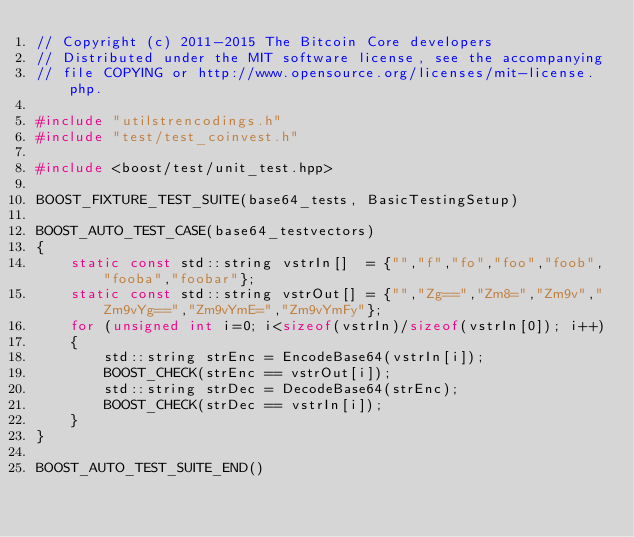<code> <loc_0><loc_0><loc_500><loc_500><_C++_>// Copyright (c) 2011-2015 The Bitcoin Core developers
// Distributed under the MIT software license, see the accompanying
// file COPYING or http://www.opensource.org/licenses/mit-license.php.

#include "utilstrencodings.h"
#include "test/test_coinvest.h"

#include <boost/test/unit_test.hpp>

BOOST_FIXTURE_TEST_SUITE(base64_tests, BasicTestingSetup)

BOOST_AUTO_TEST_CASE(base64_testvectors)
{
    static const std::string vstrIn[]  = {"","f","fo","foo","foob","fooba","foobar"};
    static const std::string vstrOut[] = {"","Zg==","Zm8=","Zm9v","Zm9vYg==","Zm9vYmE=","Zm9vYmFy"};
    for (unsigned int i=0; i<sizeof(vstrIn)/sizeof(vstrIn[0]); i++)
    {
        std::string strEnc = EncodeBase64(vstrIn[i]);
        BOOST_CHECK(strEnc == vstrOut[i]);
        std::string strDec = DecodeBase64(strEnc);
        BOOST_CHECK(strDec == vstrIn[i]);
    }
}

BOOST_AUTO_TEST_SUITE_END()
</code> 